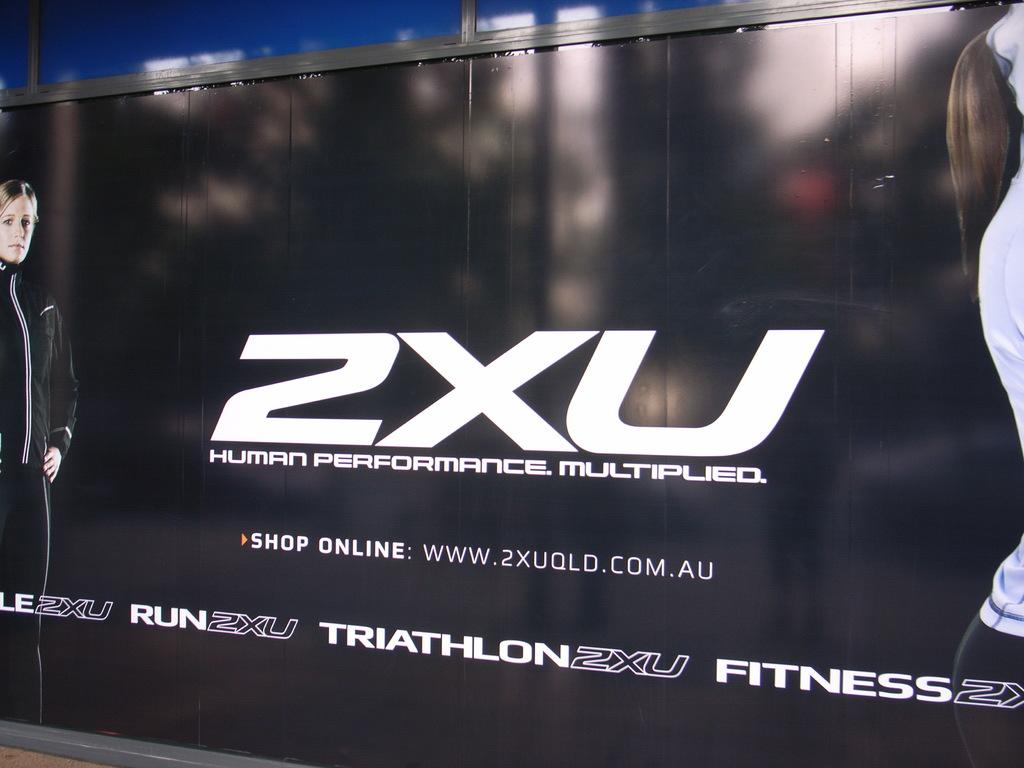What is the web address where you can shop online?
Offer a very short reply. Www.2xuqld.com.au. 